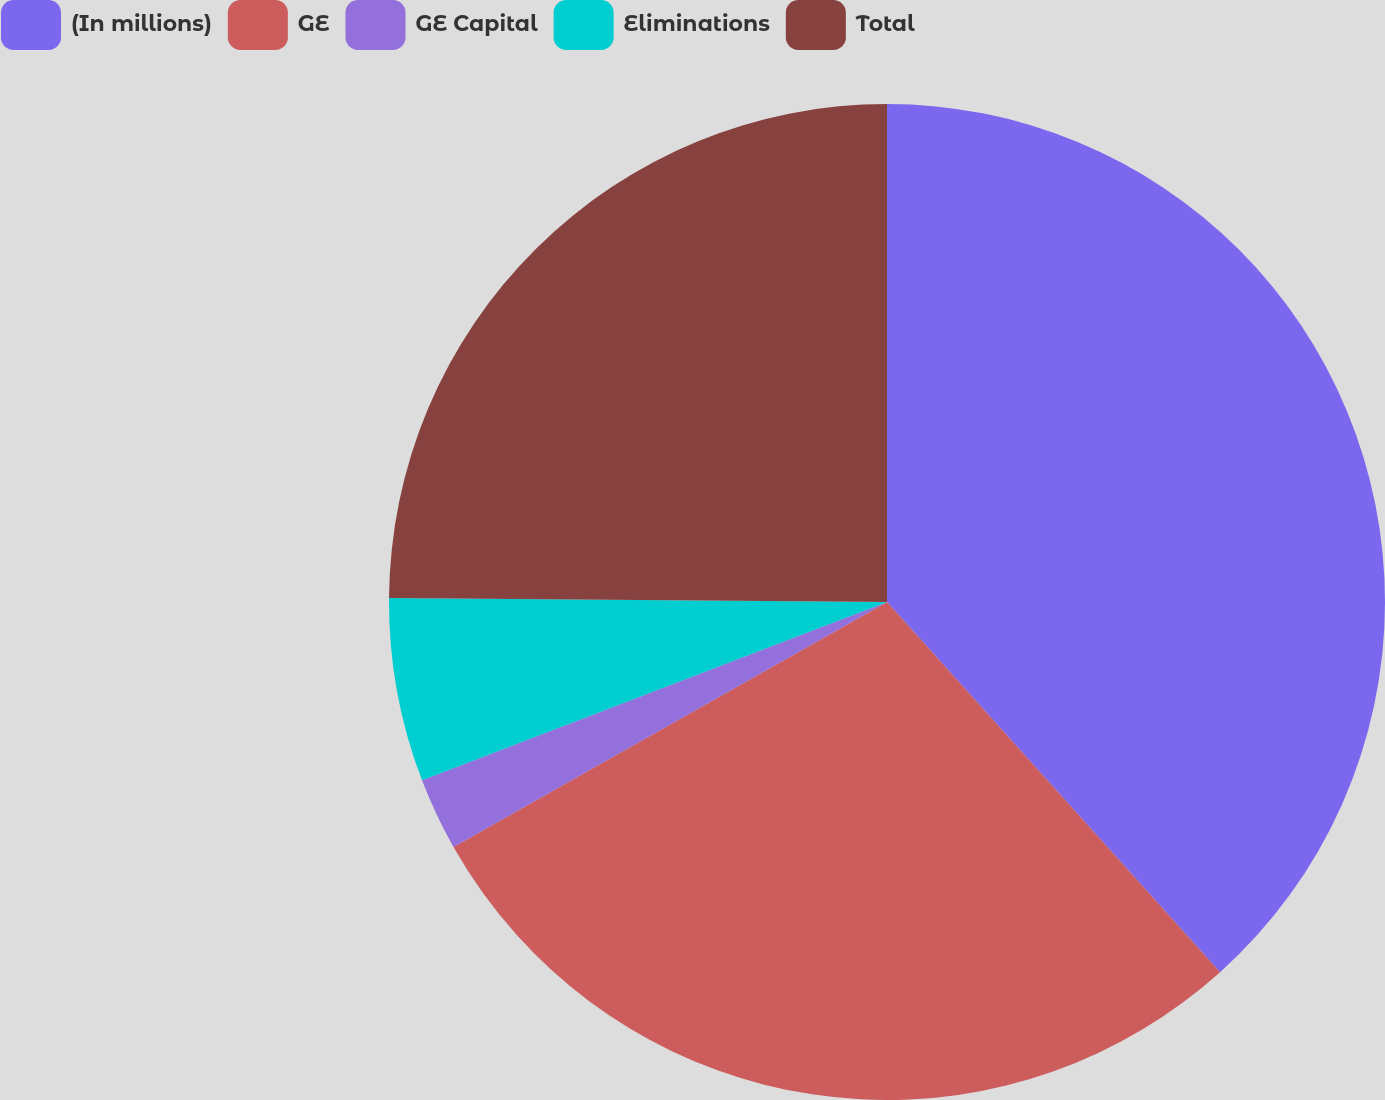Convert chart to OTSL. <chart><loc_0><loc_0><loc_500><loc_500><pie_chart><fcel>(In millions)<fcel>GE<fcel>GE Capital<fcel>Eliminations<fcel>Total<nl><fcel>38.34%<fcel>28.47%<fcel>2.36%<fcel>5.96%<fcel>24.87%<nl></chart> 